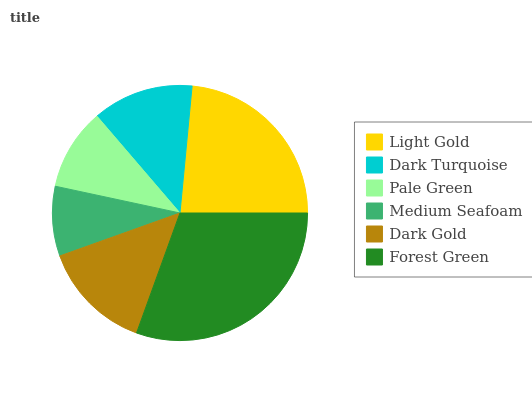Is Medium Seafoam the minimum?
Answer yes or no. Yes. Is Forest Green the maximum?
Answer yes or no. Yes. Is Dark Turquoise the minimum?
Answer yes or no. No. Is Dark Turquoise the maximum?
Answer yes or no. No. Is Light Gold greater than Dark Turquoise?
Answer yes or no. Yes. Is Dark Turquoise less than Light Gold?
Answer yes or no. Yes. Is Dark Turquoise greater than Light Gold?
Answer yes or no. No. Is Light Gold less than Dark Turquoise?
Answer yes or no. No. Is Dark Gold the high median?
Answer yes or no. Yes. Is Dark Turquoise the low median?
Answer yes or no. Yes. Is Light Gold the high median?
Answer yes or no. No. Is Forest Green the low median?
Answer yes or no. No. 